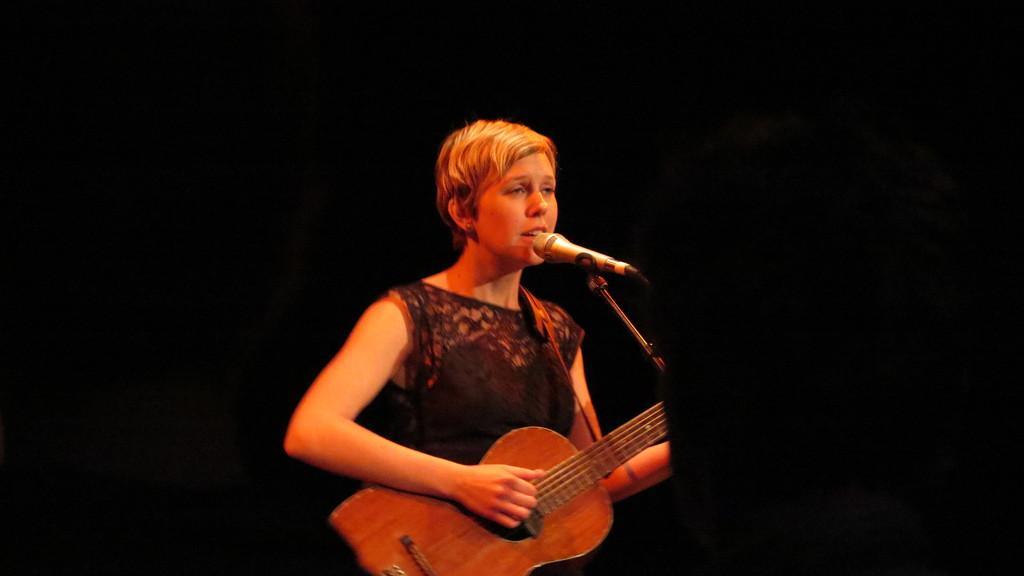Describe this image in one or two sentences. In the middle there is a lady with black dress is standing and playing guitar. In front of her there is a mic. She is singing. 